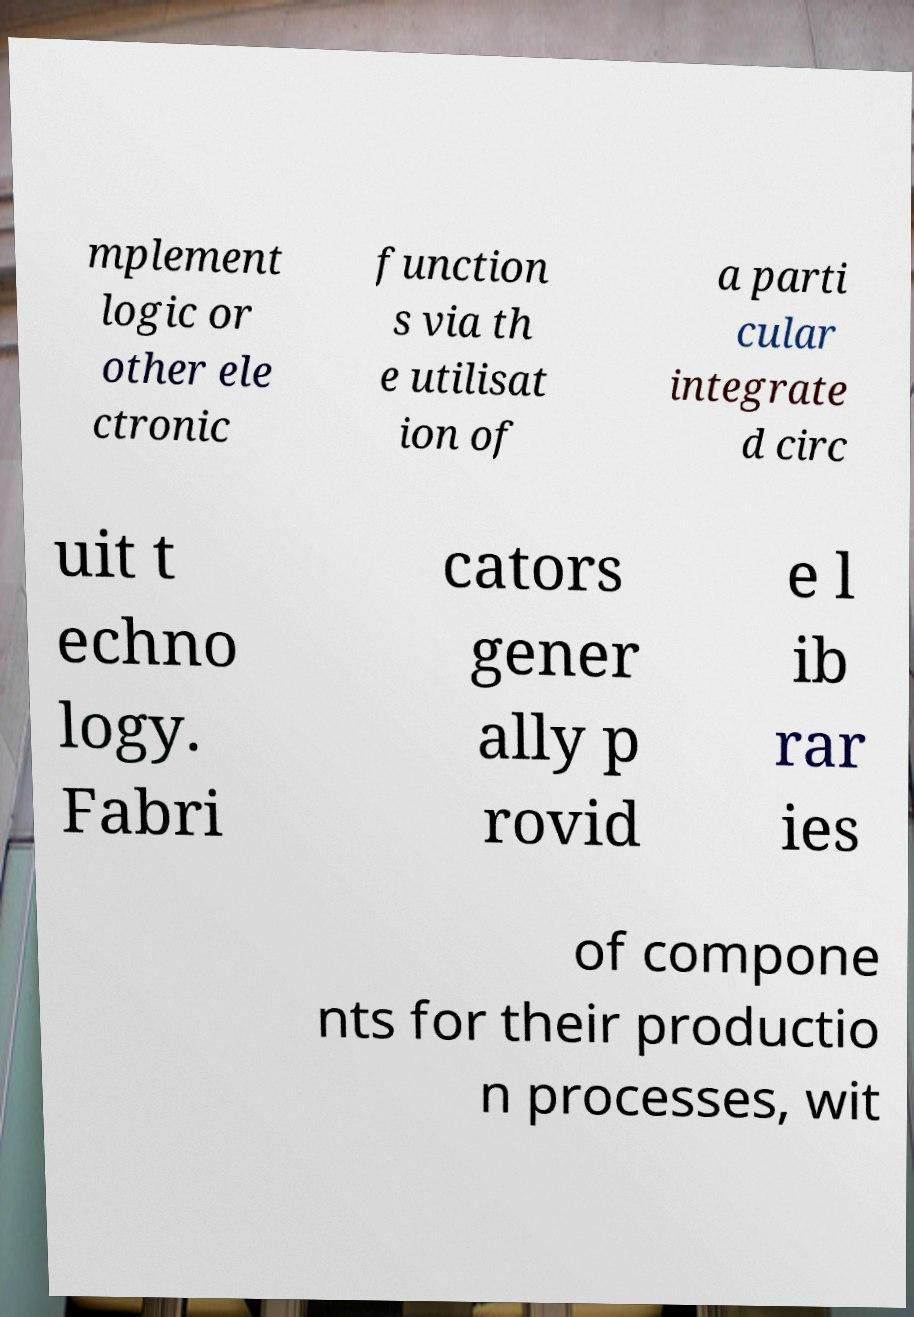For documentation purposes, I need the text within this image transcribed. Could you provide that? mplement logic or other ele ctronic function s via th e utilisat ion of a parti cular integrate d circ uit t echno logy. Fabri cators gener ally p rovid e l ib rar ies of compone nts for their productio n processes, wit 